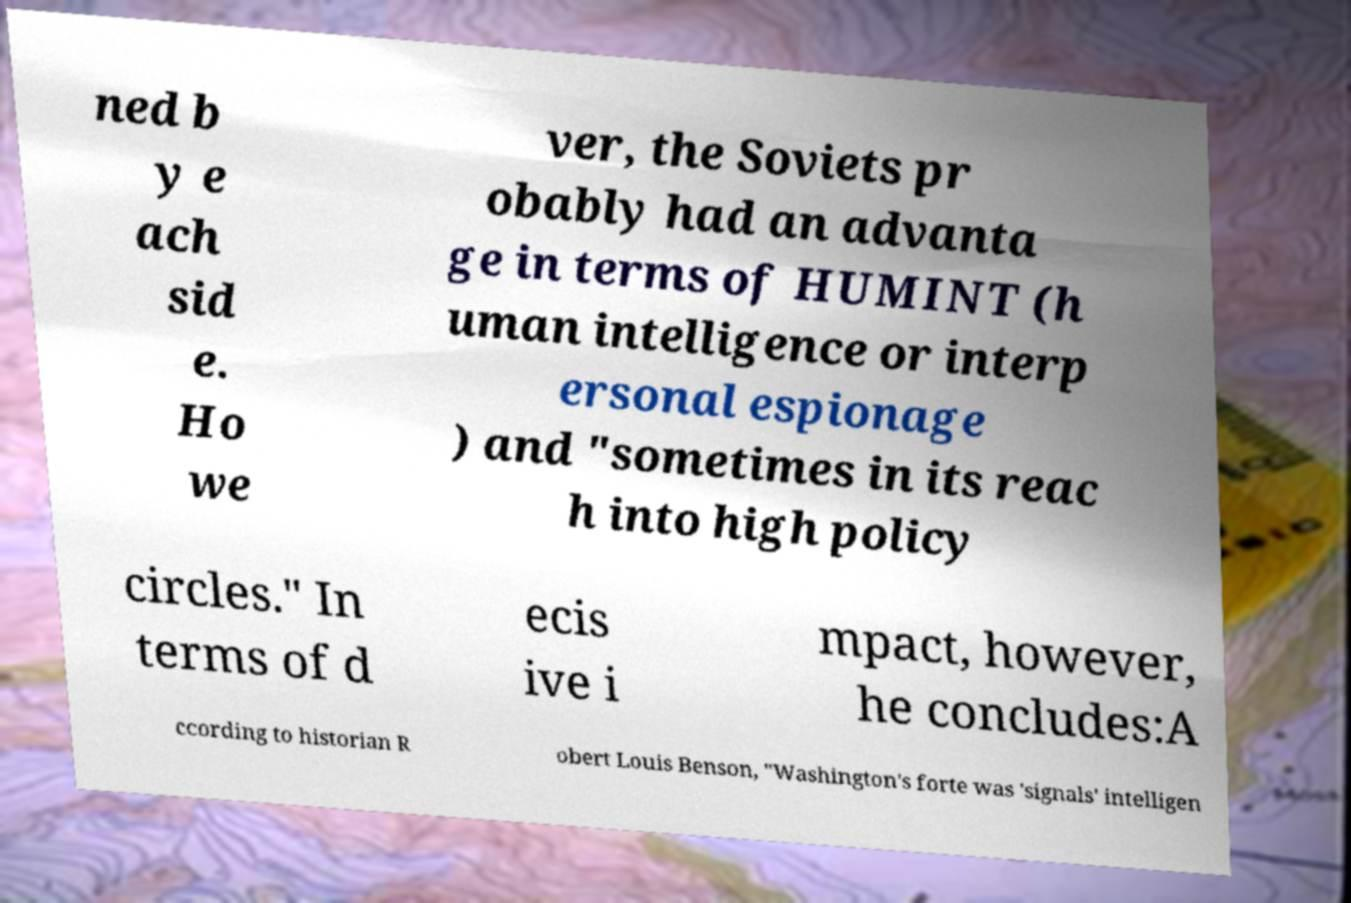Can you read and provide the text displayed in the image?This photo seems to have some interesting text. Can you extract and type it out for me? ned b y e ach sid e. Ho we ver, the Soviets pr obably had an advanta ge in terms of HUMINT (h uman intelligence or interp ersonal espionage ) and "sometimes in its reac h into high policy circles." In terms of d ecis ive i mpact, however, he concludes:A ccording to historian R obert Louis Benson, "Washington's forte was 'signals' intelligen 